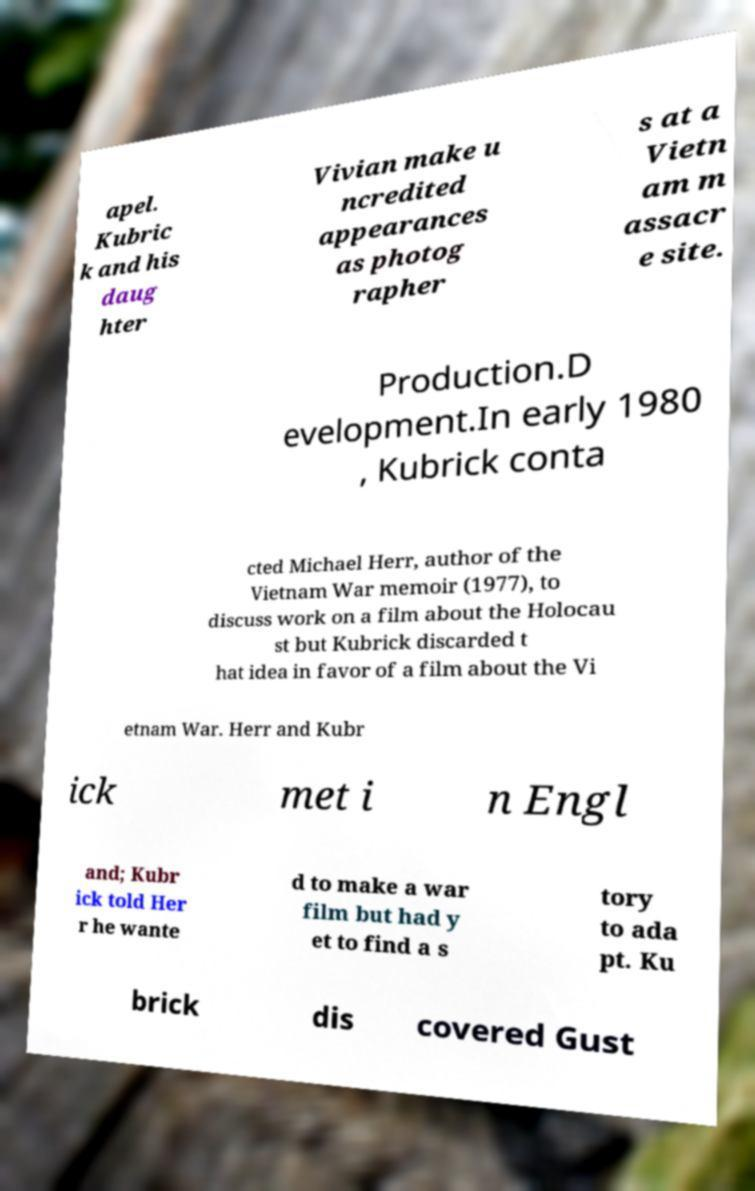What messages or text are displayed in this image? I need them in a readable, typed format. apel. Kubric k and his daug hter Vivian make u ncredited appearances as photog rapher s at a Vietn am m assacr e site. Production.D evelopment.In early 1980 , Kubrick conta cted Michael Herr, author of the Vietnam War memoir (1977), to discuss work on a film about the Holocau st but Kubrick discarded t hat idea in favor of a film about the Vi etnam War. Herr and Kubr ick met i n Engl and; Kubr ick told Her r he wante d to make a war film but had y et to find a s tory to ada pt. Ku brick dis covered Gust 